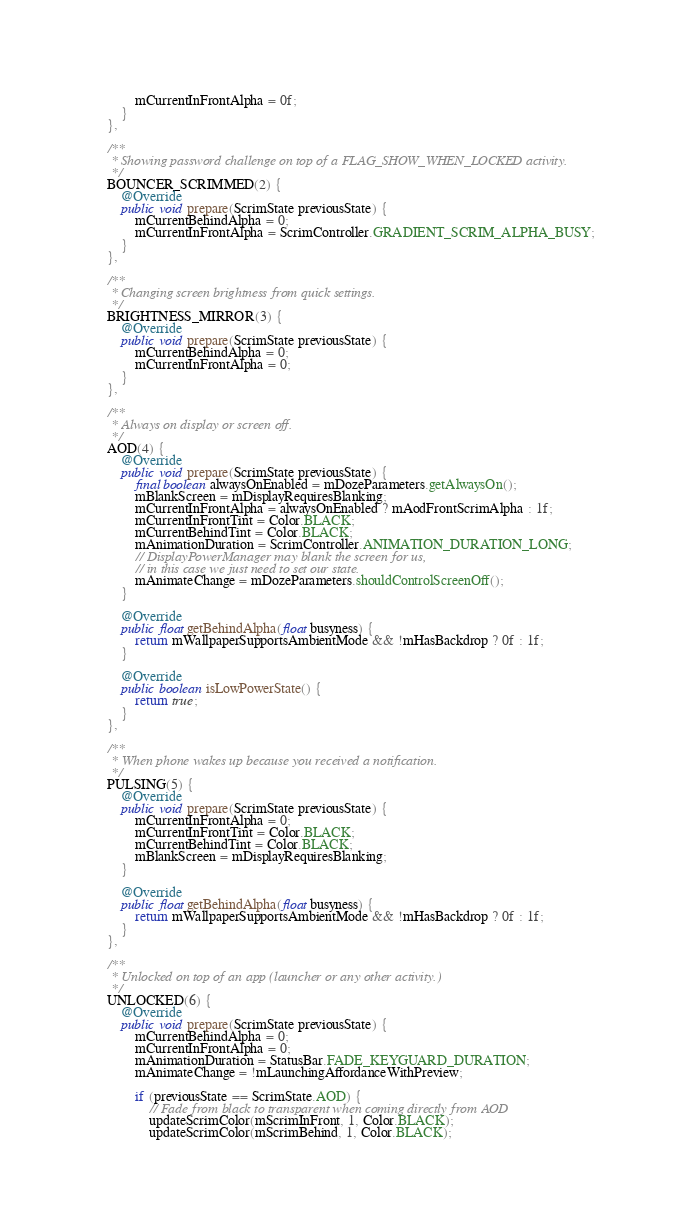<code> <loc_0><loc_0><loc_500><loc_500><_Java_>            mCurrentInFrontAlpha = 0f;
        }
    },

    /**
     * Showing password challenge on top of a FLAG_SHOW_WHEN_LOCKED activity.
     */
    BOUNCER_SCRIMMED(2) {
        @Override
        public void prepare(ScrimState previousState) {
            mCurrentBehindAlpha = 0;
            mCurrentInFrontAlpha = ScrimController.GRADIENT_SCRIM_ALPHA_BUSY;
        }
    },

    /**
     * Changing screen brightness from quick settings.
     */
    BRIGHTNESS_MIRROR(3) {
        @Override
        public void prepare(ScrimState previousState) {
            mCurrentBehindAlpha = 0;
            mCurrentInFrontAlpha = 0;
        }
    },

    /**
     * Always on display or screen off.
     */
    AOD(4) {
        @Override
        public void prepare(ScrimState previousState) {
            final boolean alwaysOnEnabled = mDozeParameters.getAlwaysOn();
            mBlankScreen = mDisplayRequiresBlanking;
            mCurrentInFrontAlpha = alwaysOnEnabled ? mAodFrontScrimAlpha : 1f;
            mCurrentInFrontTint = Color.BLACK;
            mCurrentBehindTint = Color.BLACK;
            mAnimationDuration = ScrimController.ANIMATION_DURATION_LONG;
            // DisplayPowerManager may blank the screen for us,
            // in this case we just need to set our state.
            mAnimateChange = mDozeParameters.shouldControlScreenOff();
        }

        @Override
        public float getBehindAlpha(float busyness) {
            return mWallpaperSupportsAmbientMode && !mHasBackdrop ? 0f : 1f;
        }

        @Override
        public boolean isLowPowerState() {
            return true;
        }
    },

    /**
     * When phone wakes up because you received a notification.
     */
    PULSING(5) {
        @Override
        public void prepare(ScrimState previousState) {
            mCurrentInFrontAlpha = 0;
            mCurrentInFrontTint = Color.BLACK;
            mCurrentBehindTint = Color.BLACK;
            mBlankScreen = mDisplayRequiresBlanking;
        }

        @Override
        public float getBehindAlpha(float busyness) {
            return mWallpaperSupportsAmbientMode && !mHasBackdrop ? 0f : 1f;
        }
    },

    /**
     * Unlocked on top of an app (launcher or any other activity.)
     */
    UNLOCKED(6) {
        @Override
        public void prepare(ScrimState previousState) {
            mCurrentBehindAlpha = 0;
            mCurrentInFrontAlpha = 0;
            mAnimationDuration = StatusBar.FADE_KEYGUARD_DURATION;
            mAnimateChange = !mLaunchingAffordanceWithPreview;

            if (previousState == ScrimState.AOD) {
                // Fade from black to transparent when coming directly from AOD
                updateScrimColor(mScrimInFront, 1, Color.BLACK);
                updateScrimColor(mScrimBehind, 1, Color.BLACK);</code> 